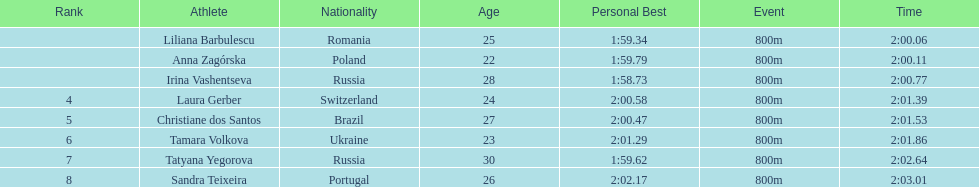Anna zagorska recieved 2nd place, what was her time? 2:00.11. 